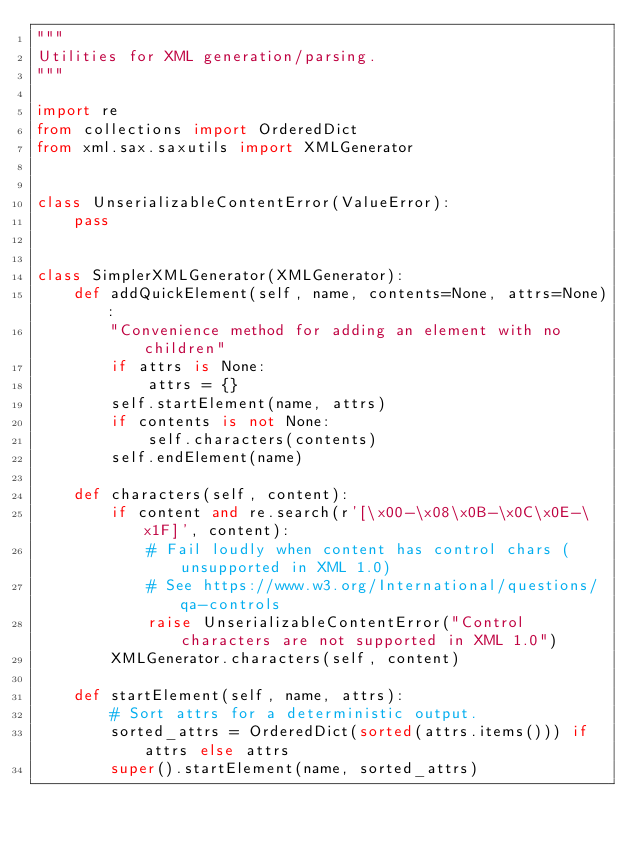<code> <loc_0><loc_0><loc_500><loc_500><_Python_>"""
Utilities for XML generation/parsing.
"""

import re
from collections import OrderedDict
from xml.sax.saxutils import XMLGenerator


class UnserializableContentError(ValueError):
    pass


class SimplerXMLGenerator(XMLGenerator):
    def addQuickElement(self, name, contents=None, attrs=None):
        "Convenience method for adding an element with no children"
        if attrs is None:
            attrs = {}
        self.startElement(name, attrs)
        if contents is not None:
            self.characters(contents)
        self.endElement(name)

    def characters(self, content):
        if content and re.search(r'[\x00-\x08\x0B-\x0C\x0E-\x1F]', content):
            # Fail loudly when content has control chars (unsupported in XML 1.0)
            # See https://www.w3.org/International/questions/qa-controls
            raise UnserializableContentError("Control characters are not supported in XML 1.0")
        XMLGenerator.characters(self, content)

    def startElement(self, name, attrs):
        # Sort attrs for a deterministic output.
        sorted_attrs = OrderedDict(sorted(attrs.items())) if attrs else attrs
        super().startElement(name, sorted_attrs)
</code> 